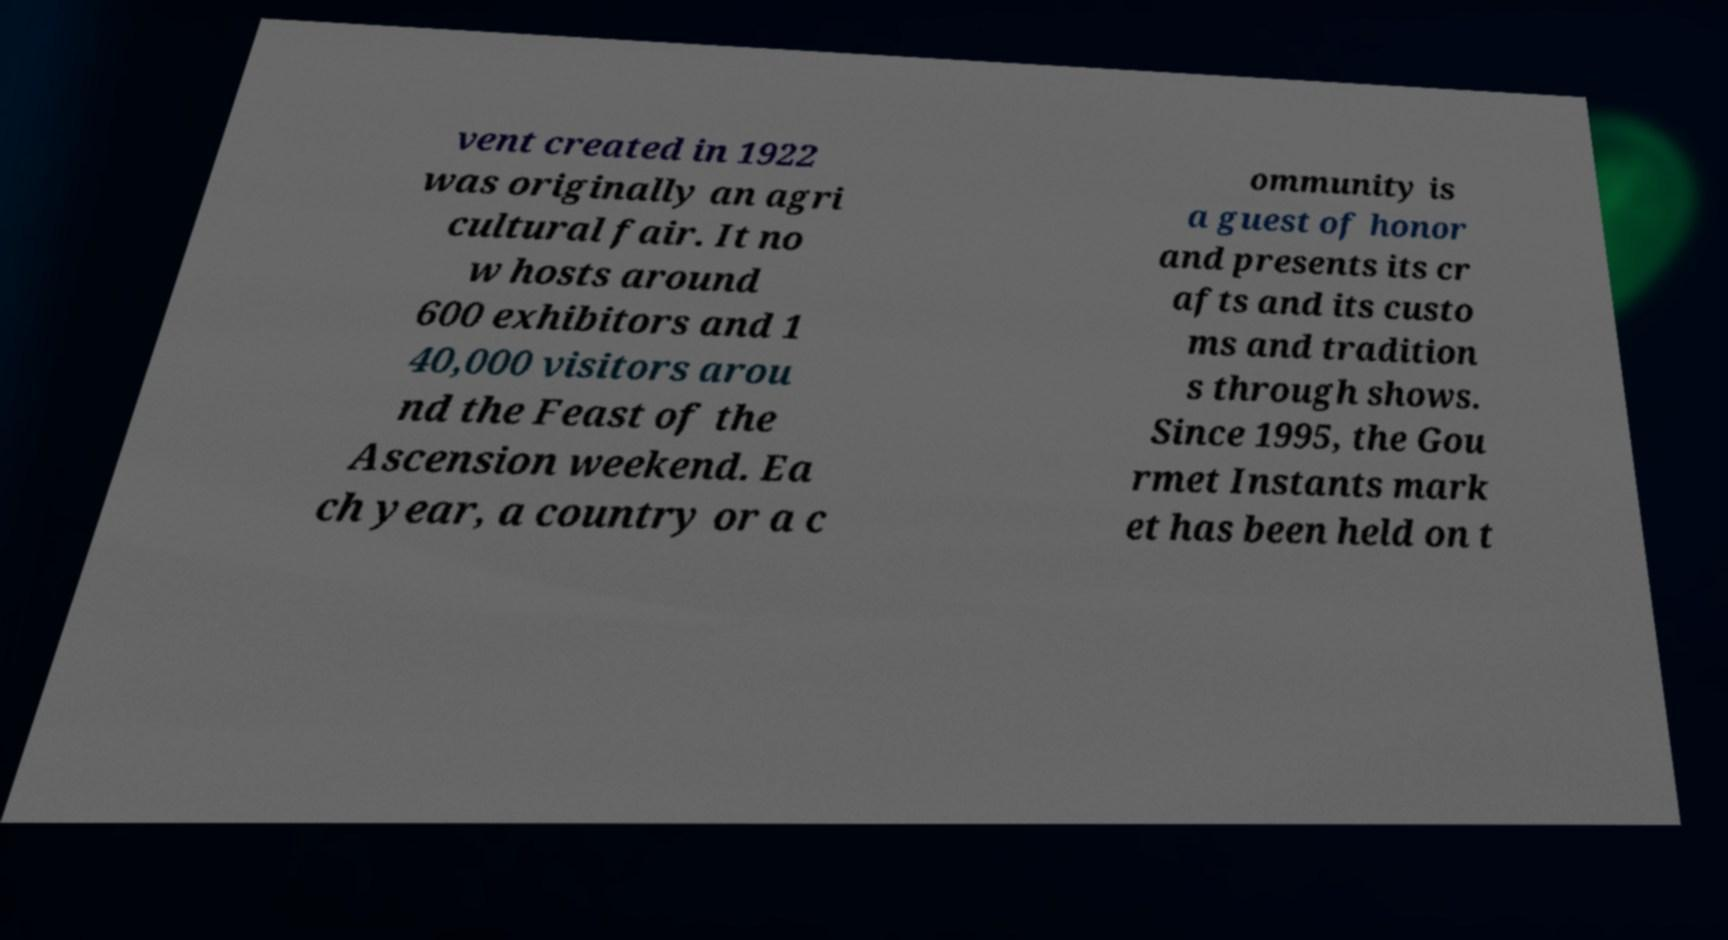For documentation purposes, I need the text within this image transcribed. Could you provide that? vent created in 1922 was originally an agri cultural fair. It no w hosts around 600 exhibitors and 1 40,000 visitors arou nd the Feast of the Ascension weekend. Ea ch year, a country or a c ommunity is a guest of honor and presents its cr afts and its custo ms and tradition s through shows. Since 1995, the Gou rmet Instants mark et has been held on t 